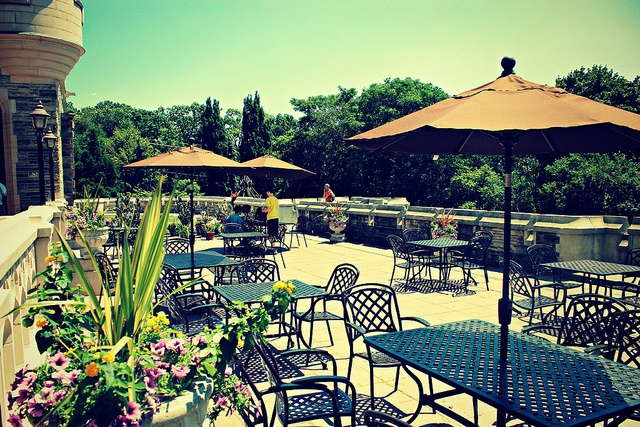Describe the objects in this image and their specific colors. I can see potted plant in black, darkgreen, and khaki tones, dining table in black, navy, blue, and teal tones, chair in black, khaki, navy, and gray tones, umbrella in black, tan, and khaki tones, and chair in black, navy, khaki, and gray tones in this image. 